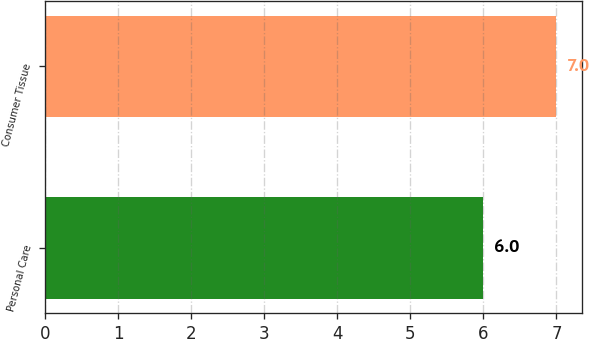<chart> <loc_0><loc_0><loc_500><loc_500><bar_chart><fcel>Personal Care<fcel>Consumer Tissue<nl><fcel>6<fcel>7<nl></chart> 